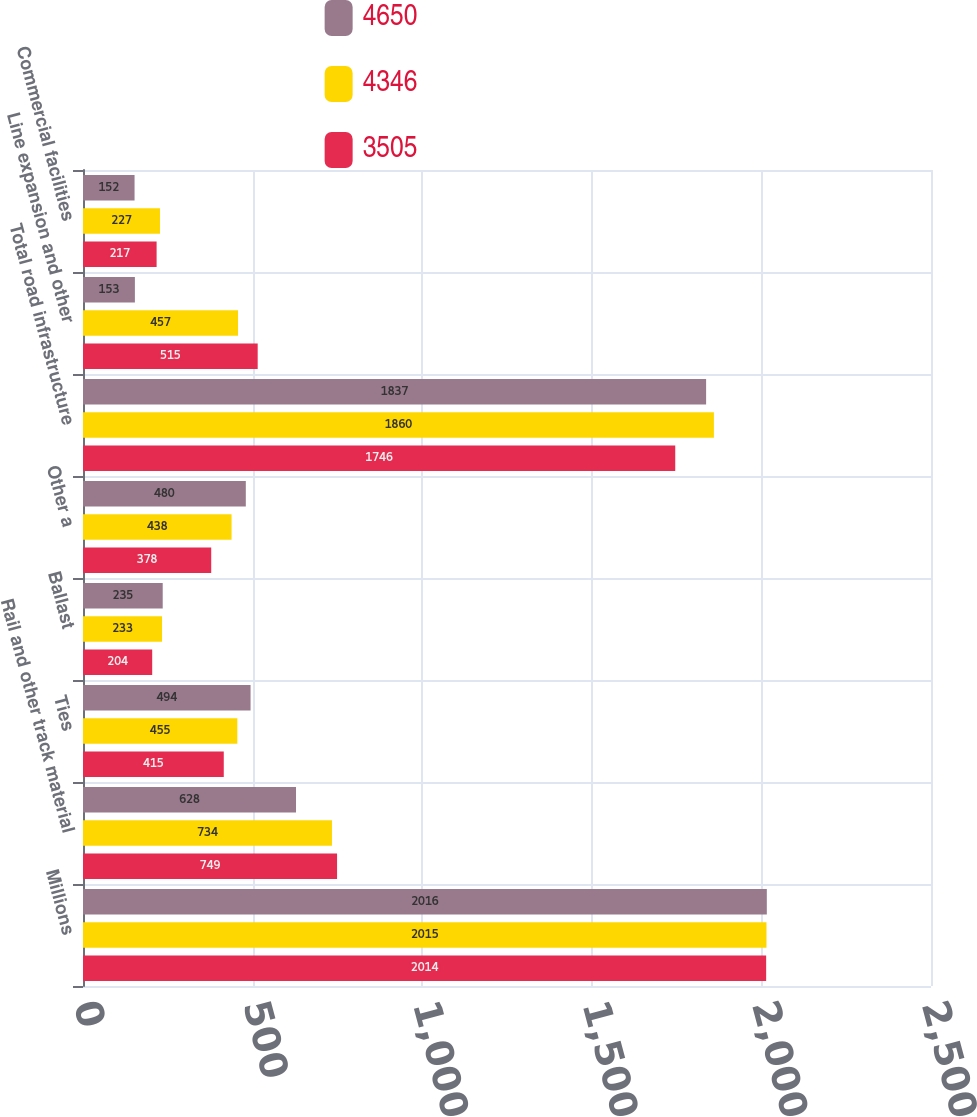Convert chart. <chart><loc_0><loc_0><loc_500><loc_500><stacked_bar_chart><ecel><fcel>Millions<fcel>Rail and other track material<fcel>Ties<fcel>Ballast<fcel>Other a<fcel>Total road infrastructure<fcel>Line expansion and other<fcel>Commercial facilities<nl><fcel>4650<fcel>2016<fcel>628<fcel>494<fcel>235<fcel>480<fcel>1837<fcel>153<fcel>152<nl><fcel>4346<fcel>2015<fcel>734<fcel>455<fcel>233<fcel>438<fcel>1860<fcel>457<fcel>227<nl><fcel>3505<fcel>2014<fcel>749<fcel>415<fcel>204<fcel>378<fcel>1746<fcel>515<fcel>217<nl></chart> 